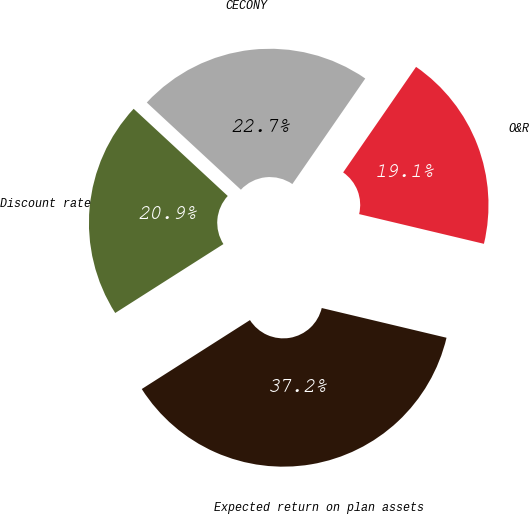<chart> <loc_0><loc_0><loc_500><loc_500><pie_chart><fcel>Discount rate<fcel>CECONY<fcel>O&R<fcel>Expected return on plan assets<nl><fcel>20.92%<fcel>22.73%<fcel>19.1%<fcel>37.25%<nl></chart> 